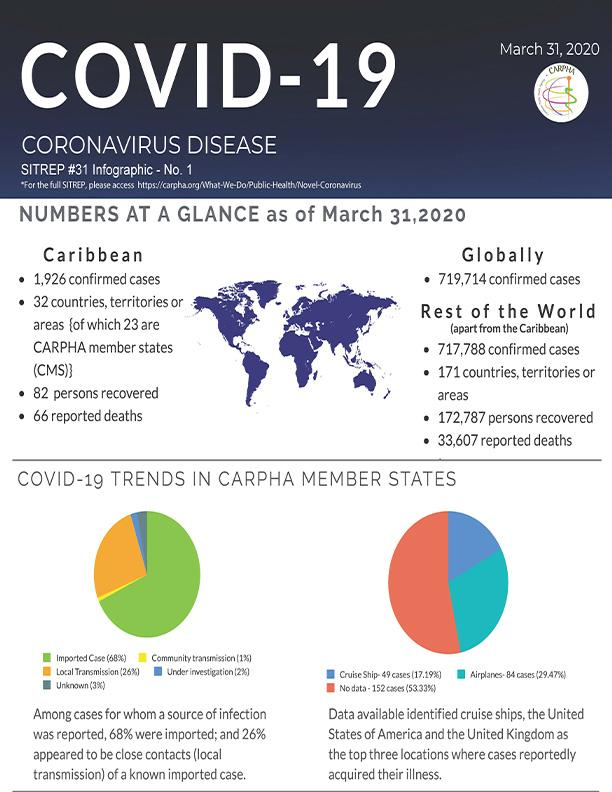Identify some key points in this picture. The pie chart represents community transmission through yellow, blue, and green sectors. In my opinion, airplanes are the locations where people are more likely to acquire illness compared to cruise ships. According to CARPHA member states, the COVID-19 trend represented by green color is imported cases, accounting for 68% of all cases. 